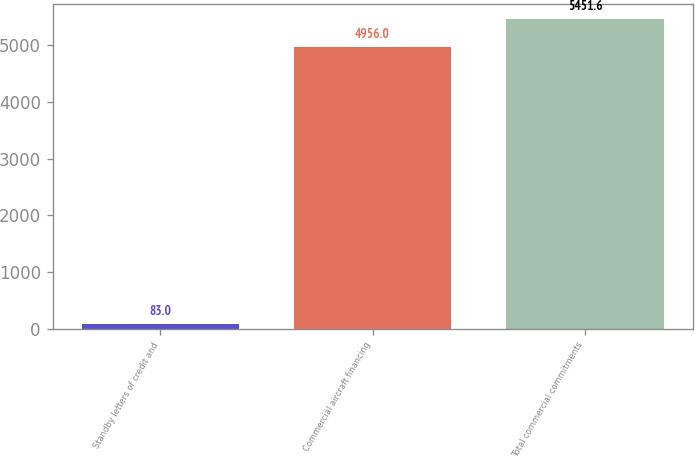Convert chart to OTSL. <chart><loc_0><loc_0><loc_500><loc_500><bar_chart><fcel>Standby letters of credit and<fcel>Commercial aircraft financing<fcel>Total commercial commitments<nl><fcel>83<fcel>4956<fcel>5451.6<nl></chart> 